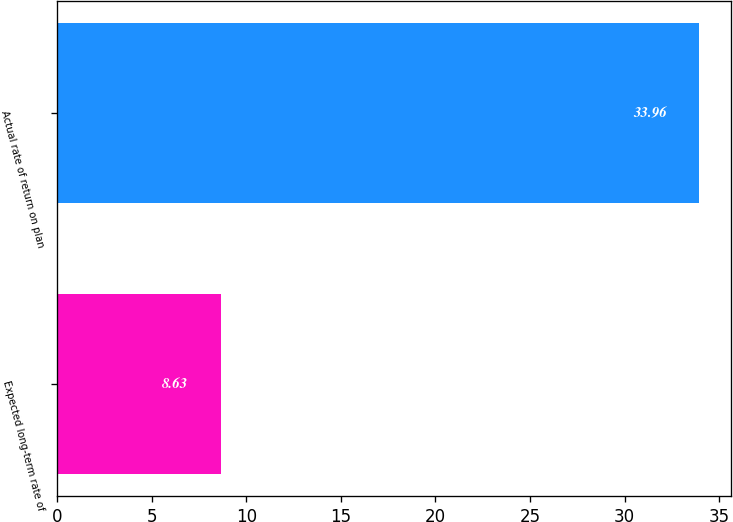Convert chart to OTSL. <chart><loc_0><loc_0><loc_500><loc_500><bar_chart><fcel>Expected long-term rate of<fcel>Actual rate of return on plan<nl><fcel>8.63<fcel>33.96<nl></chart> 